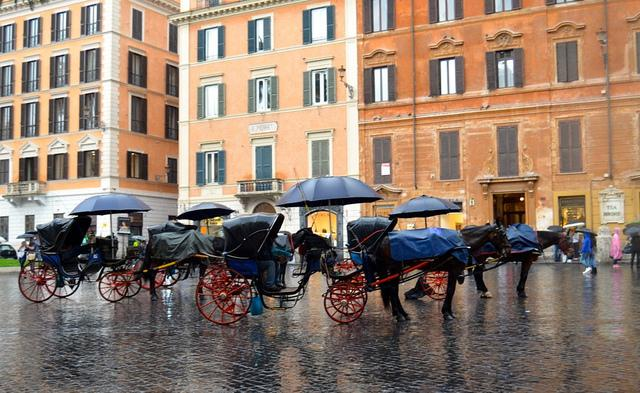What group usually uses this mode of transport?

Choices:
A) amish
B) paratroopers
C) army rangers
D) pilots amish 